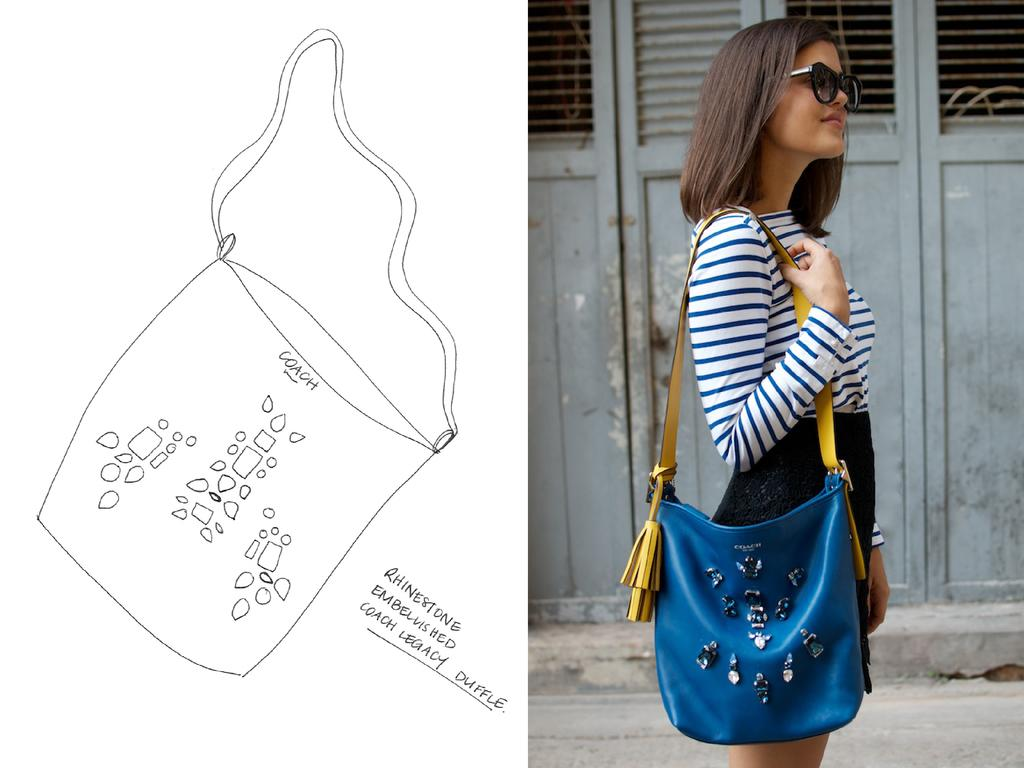Who is present on the right side of the image? There is a woman standing on the right side of the image. What is the woman holding in the image? The woman is holding a handbag. What can be seen on the left side of the image? There is a paper with "Coach" written on it on the left side of the image. What architectural feature is visible in the image? There is a door visible in the image. What type of doll is wearing a crown on the woman's head in the image? There is no doll or crown present on the woman's head in the image. 